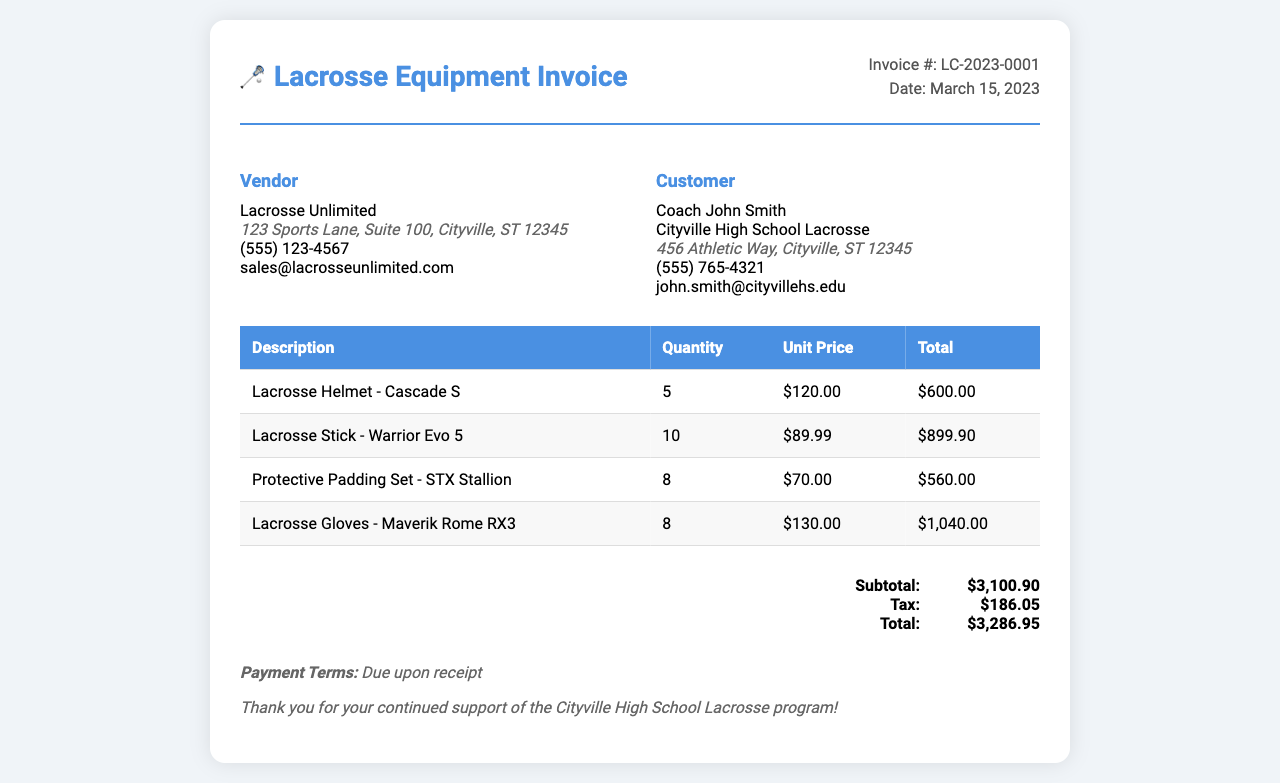what is the invoice number? The invoice number is stated in the invoice header for reference purposes.
Answer: LC-2023-0001 what is the total amount due? The total amount due is the final amount calculated at the end of the invoice.
Answer: $3,286.95 who is the vendor? The vendor is the organization providing the goods, mentioned in the vendor section of the invoice.
Answer: Lacrosse Unlimited how many lacrosse sticks were purchased? The quantity of lacrosse sticks is listed in the itemized list of the invoice.
Answer: 10 what was the subtotal before tax? The subtotal represents the total cost of goods before any tax is applied, shown in the total section.
Answer: $3,100.90 what is the date of the invoice? The invoice date indicates when the transaction was recorded and is displayed near the invoice number.
Answer: March 15, 2023 what is the unit price of the lacrosse helmet? The unit price for the lacrosse helmet is specified in the invoice's itemized section under unit price.
Answer: $120.00 how many protective padding sets were purchased? The number of protective padding sets purchased is clearly stated in the invoice's itemized list.
Answer: 8 what are the payment terms mentioned in the invoice? The payment terms outline when payment is expected and are noted in the invoice.
Answer: Due upon receipt 